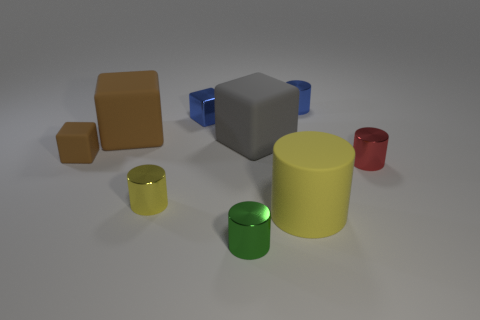Subtract all tiny yellow rubber cylinders. Subtract all red metallic cylinders. How many objects are left? 8 Add 8 gray blocks. How many gray blocks are left? 9 Add 2 blue shiny cylinders. How many blue shiny cylinders exist? 3 Add 1 tiny brown cubes. How many objects exist? 10 Subtract all blue cubes. How many cubes are left? 3 Subtract all tiny blue metallic cylinders. How many cylinders are left? 4 Subtract 0 purple cylinders. How many objects are left? 9 Subtract all cubes. How many objects are left? 5 Subtract 1 cylinders. How many cylinders are left? 4 Subtract all yellow cubes. Subtract all brown spheres. How many cubes are left? 4 